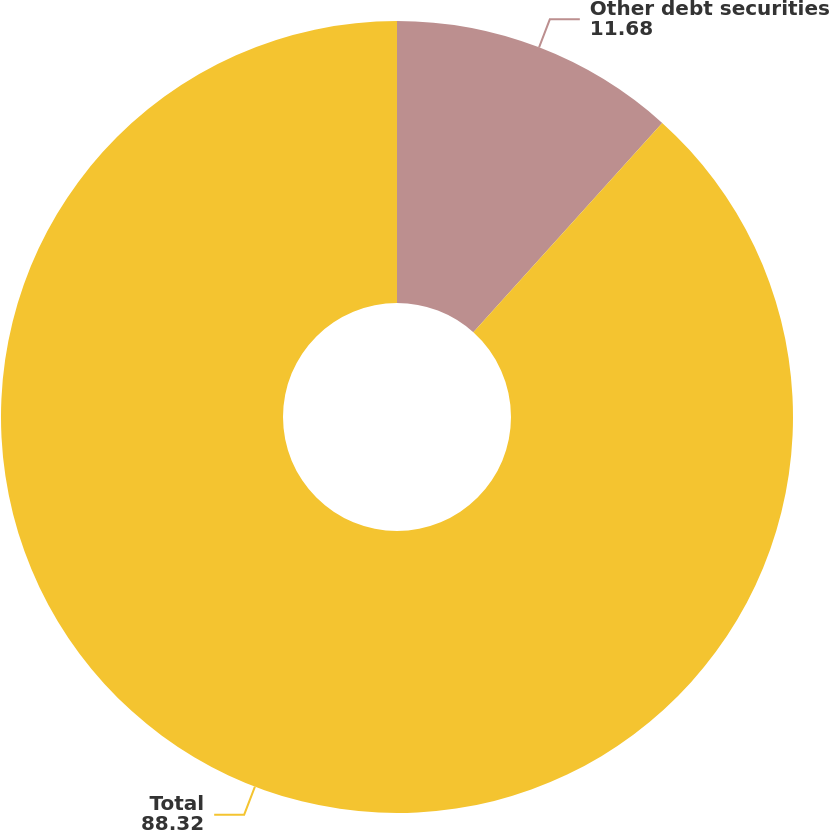Convert chart. <chart><loc_0><loc_0><loc_500><loc_500><pie_chart><fcel>Other debt securities<fcel>Total<nl><fcel>11.68%<fcel>88.32%<nl></chart> 